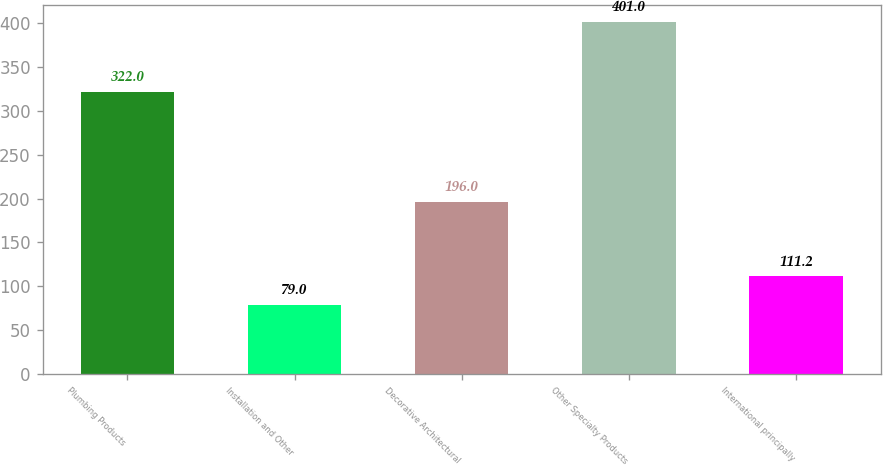Convert chart. <chart><loc_0><loc_0><loc_500><loc_500><bar_chart><fcel>Plumbing Products<fcel>Installation and Other<fcel>Decorative Architectural<fcel>Other Specialty Products<fcel>International principally<nl><fcel>322<fcel>79<fcel>196<fcel>401<fcel>111.2<nl></chart> 